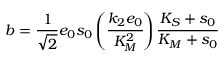<formula> <loc_0><loc_0><loc_500><loc_500>b = \frac { 1 } { \sqrt { 2 } } e _ { 0 } s _ { 0 } \left ( \cfrac { k _ { 2 } e _ { 0 } } { K _ { M } ^ { 2 } } \right ) \cfrac { K _ { S } + s _ { 0 } } { K _ { M } + s _ { 0 } }</formula> 